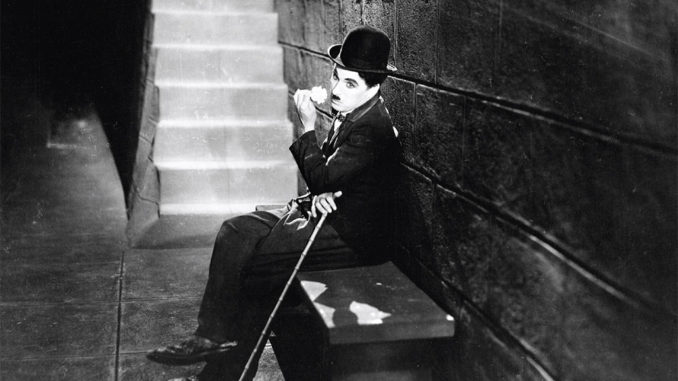Can you imagine what life would be like for the Tramp character in today's world? If the Tramp were transplanted into today's world, he would find a society much changed yet still familiar in its trials. He'd navigate the crowded urban landscapes between high-rise buildings and bustling streets. Ever resourceful, the Tramp might find temporary employment through gig economy apps, his old cane replaced by a smartphone—a modern tool for the perennial search for work. He’d charm passersby with impromptu street performances, capturing moments of joy on social media, his antics going viral, and thus securing a fleeting internet fame. Despite the technological advances, the Tramp's quintessential spirit of resilience and kindness would remain, a timeless commentary on human perseverance amidst hardship. 